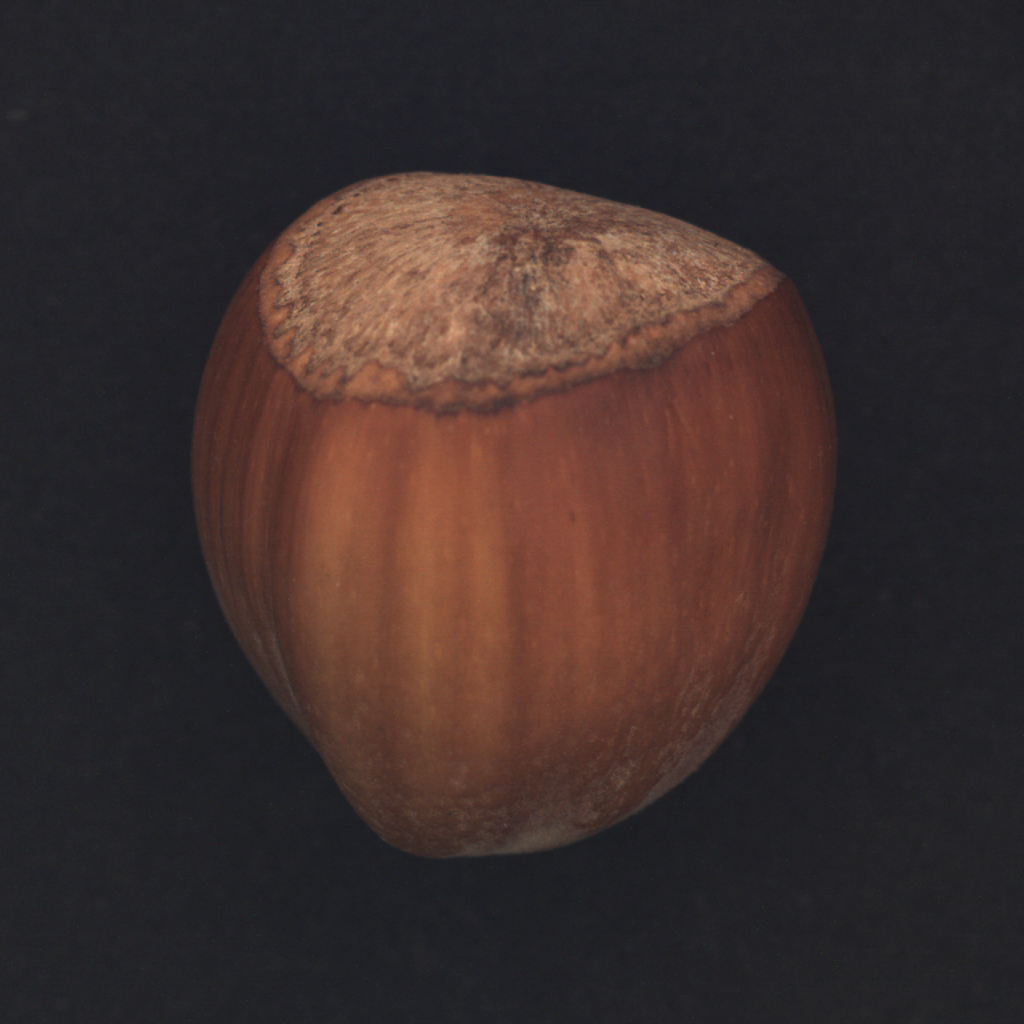Your objective is to classify an image based on its corresponding object category. The image provided encompasses a diverse range of industrial items, including a bottle, cable, carpet, and more. Focus on the overall visual appearance of the image, paying attention to details such as lines, shading, color scheme, and level of detail. It is crucial to analyze the distinctive characteristics of the object, such as its shape, color, and texture, as these features may vary significantly between different object categories. Once you have completed the classification process, output the appropriate object name based on your analysis. Upon examining the image, the object belongs to the 'food' category and it can be specifically classified as a 'hazelnut.' This classification comes from observing its smooth, elliptical shape, and textured cap, typical characteristics of hazelnuts. The color of the hazelnut transitions from a light, creamy brown at its base to a darker brown towards the top, which is natural for hazelnuts. The matte finish on its surface and rough, fibrous texture at the cap contribute to its identification. All these combined physical attributes confirm the object in the image as a 'hazelnut.' 